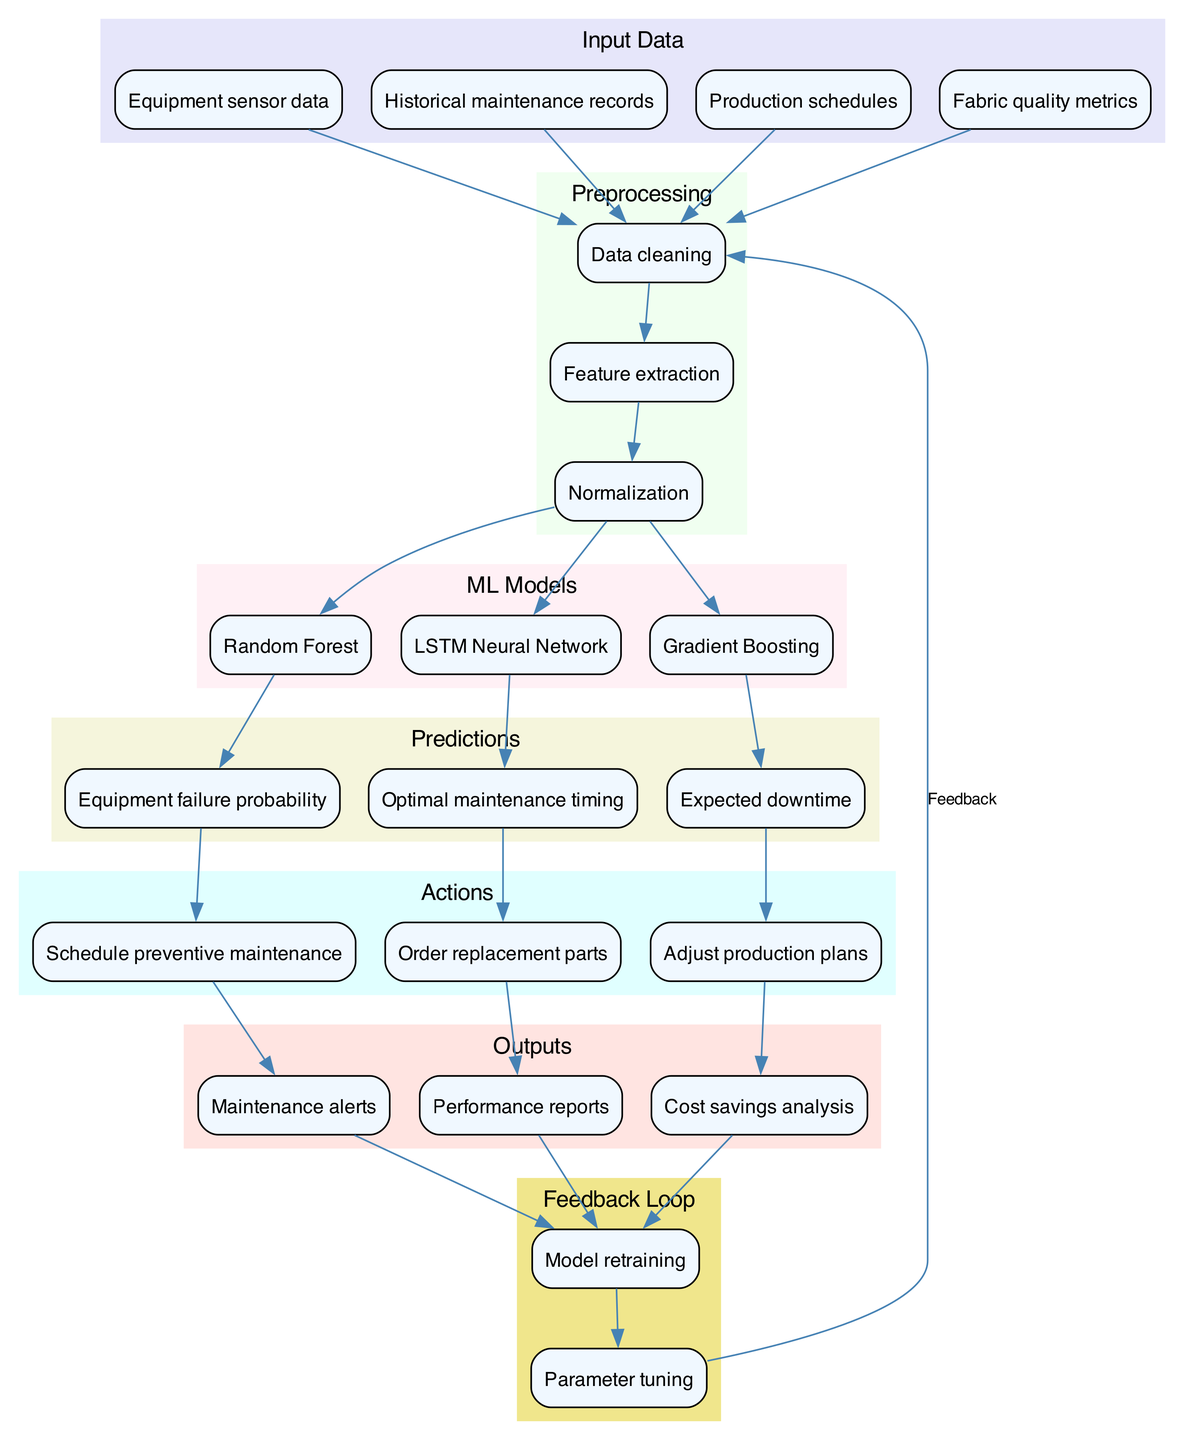What are the input data sources for the system? The diagram lists four input data sources: Equipment sensor data, Historical maintenance records, Production schedules, and Fabric quality metrics. These items are nodes in the "Input Data" subgraph.
Answer: Equipment sensor data, Historical maintenance records, Production schedules, Fabric quality metrics How many preprocessing steps are there in the diagram? The diagram shows three preprocessing steps: Data cleaning, Feature extraction, and Normalization, which can be counted in the "Preprocessing" subgraph.
Answer: 3 Which machine learning model predicts the optimal maintenance timing? The LSTM Neural Network node is connected to the Optimal maintenance timing prediction node, indicating that it is responsible for this specific output.
Answer: LSTM Neural Network What action is taken based on the expected downtime prediction? The expected downtime is connected to the node labeled "Adjust production plans," indicating that this action is taken as a response to the expected downtime.
Answer: Adjust production plans What is the purpose of the feedback loop in this diagram? The feedback loop includes components like Model retraining and Parameter tuning, which aim to improve the performance of the predictive maintenance system by continuously refining the models based on output metrics. This iterative process enhances accuracy and reliability.
Answer: Improve performance Which output results from scheduling preventive maintenance? The node Maintenance alerts is connected to Schedule preventive maintenance, indicating that scheduling this maintenance leads to the generation of alerts related to maintenance needs.
Answer: Maintenance alerts What is the final output of the parameter tuning step in the feedback loop? The feedback loop shows that Parameter tuning connects back to Data cleaning, indicating that after tuning parameters, the process will refresh or clean the data for improved results.
Answer: Data cleaning How many actions are linked to the predictions? Three actions are linked to the predictions: Schedule preventive maintenance, Order replacement parts, and Adjust production plans; these can be counted in the "Actions" subgraph indicated in the diagram.
Answer: 3 